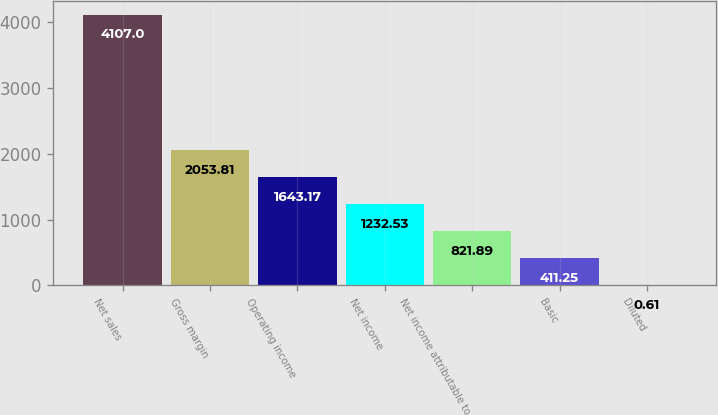<chart> <loc_0><loc_0><loc_500><loc_500><bar_chart><fcel>Net sales<fcel>Gross margin<fcel>Operating income<fcel>Net income<fcel>Net income attributable to<fcel>Basic<fcel>Diluted<nl><fcel>4107<fcel>2053.81<fcel>1643.17<fcel>1232.53<fcel>821.89<fcel>411.25<fcel>0.61<nl></chart> 